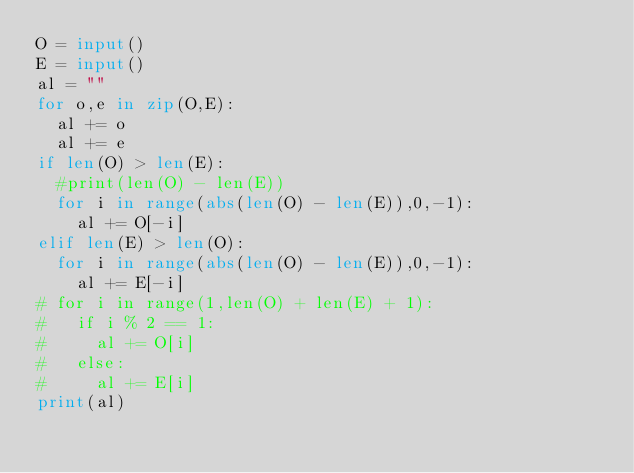Convert code to text. <code><loc_0><loc_0><loc_500><loc_500><_Python_>O = input()
E = input()
al = ""
for o,e in zip(O,E):
  al += o
  al += e
if len(O) > len(E):
  #print(len(O) - len(E))
  for i in range(abs(len(O) - len(E)),0,-1):
    al += O[-i]
elif len(E) > len(O):
  for i in range(abs(len(O) - len(E)),0,-1):
    al += E[-i]
# for i in range(1,len(O) + len(E) + 1):
#   if i % 2 == 1:
#     al += O[i]
#   else:
#     al += E[i]
print(al)</code> 